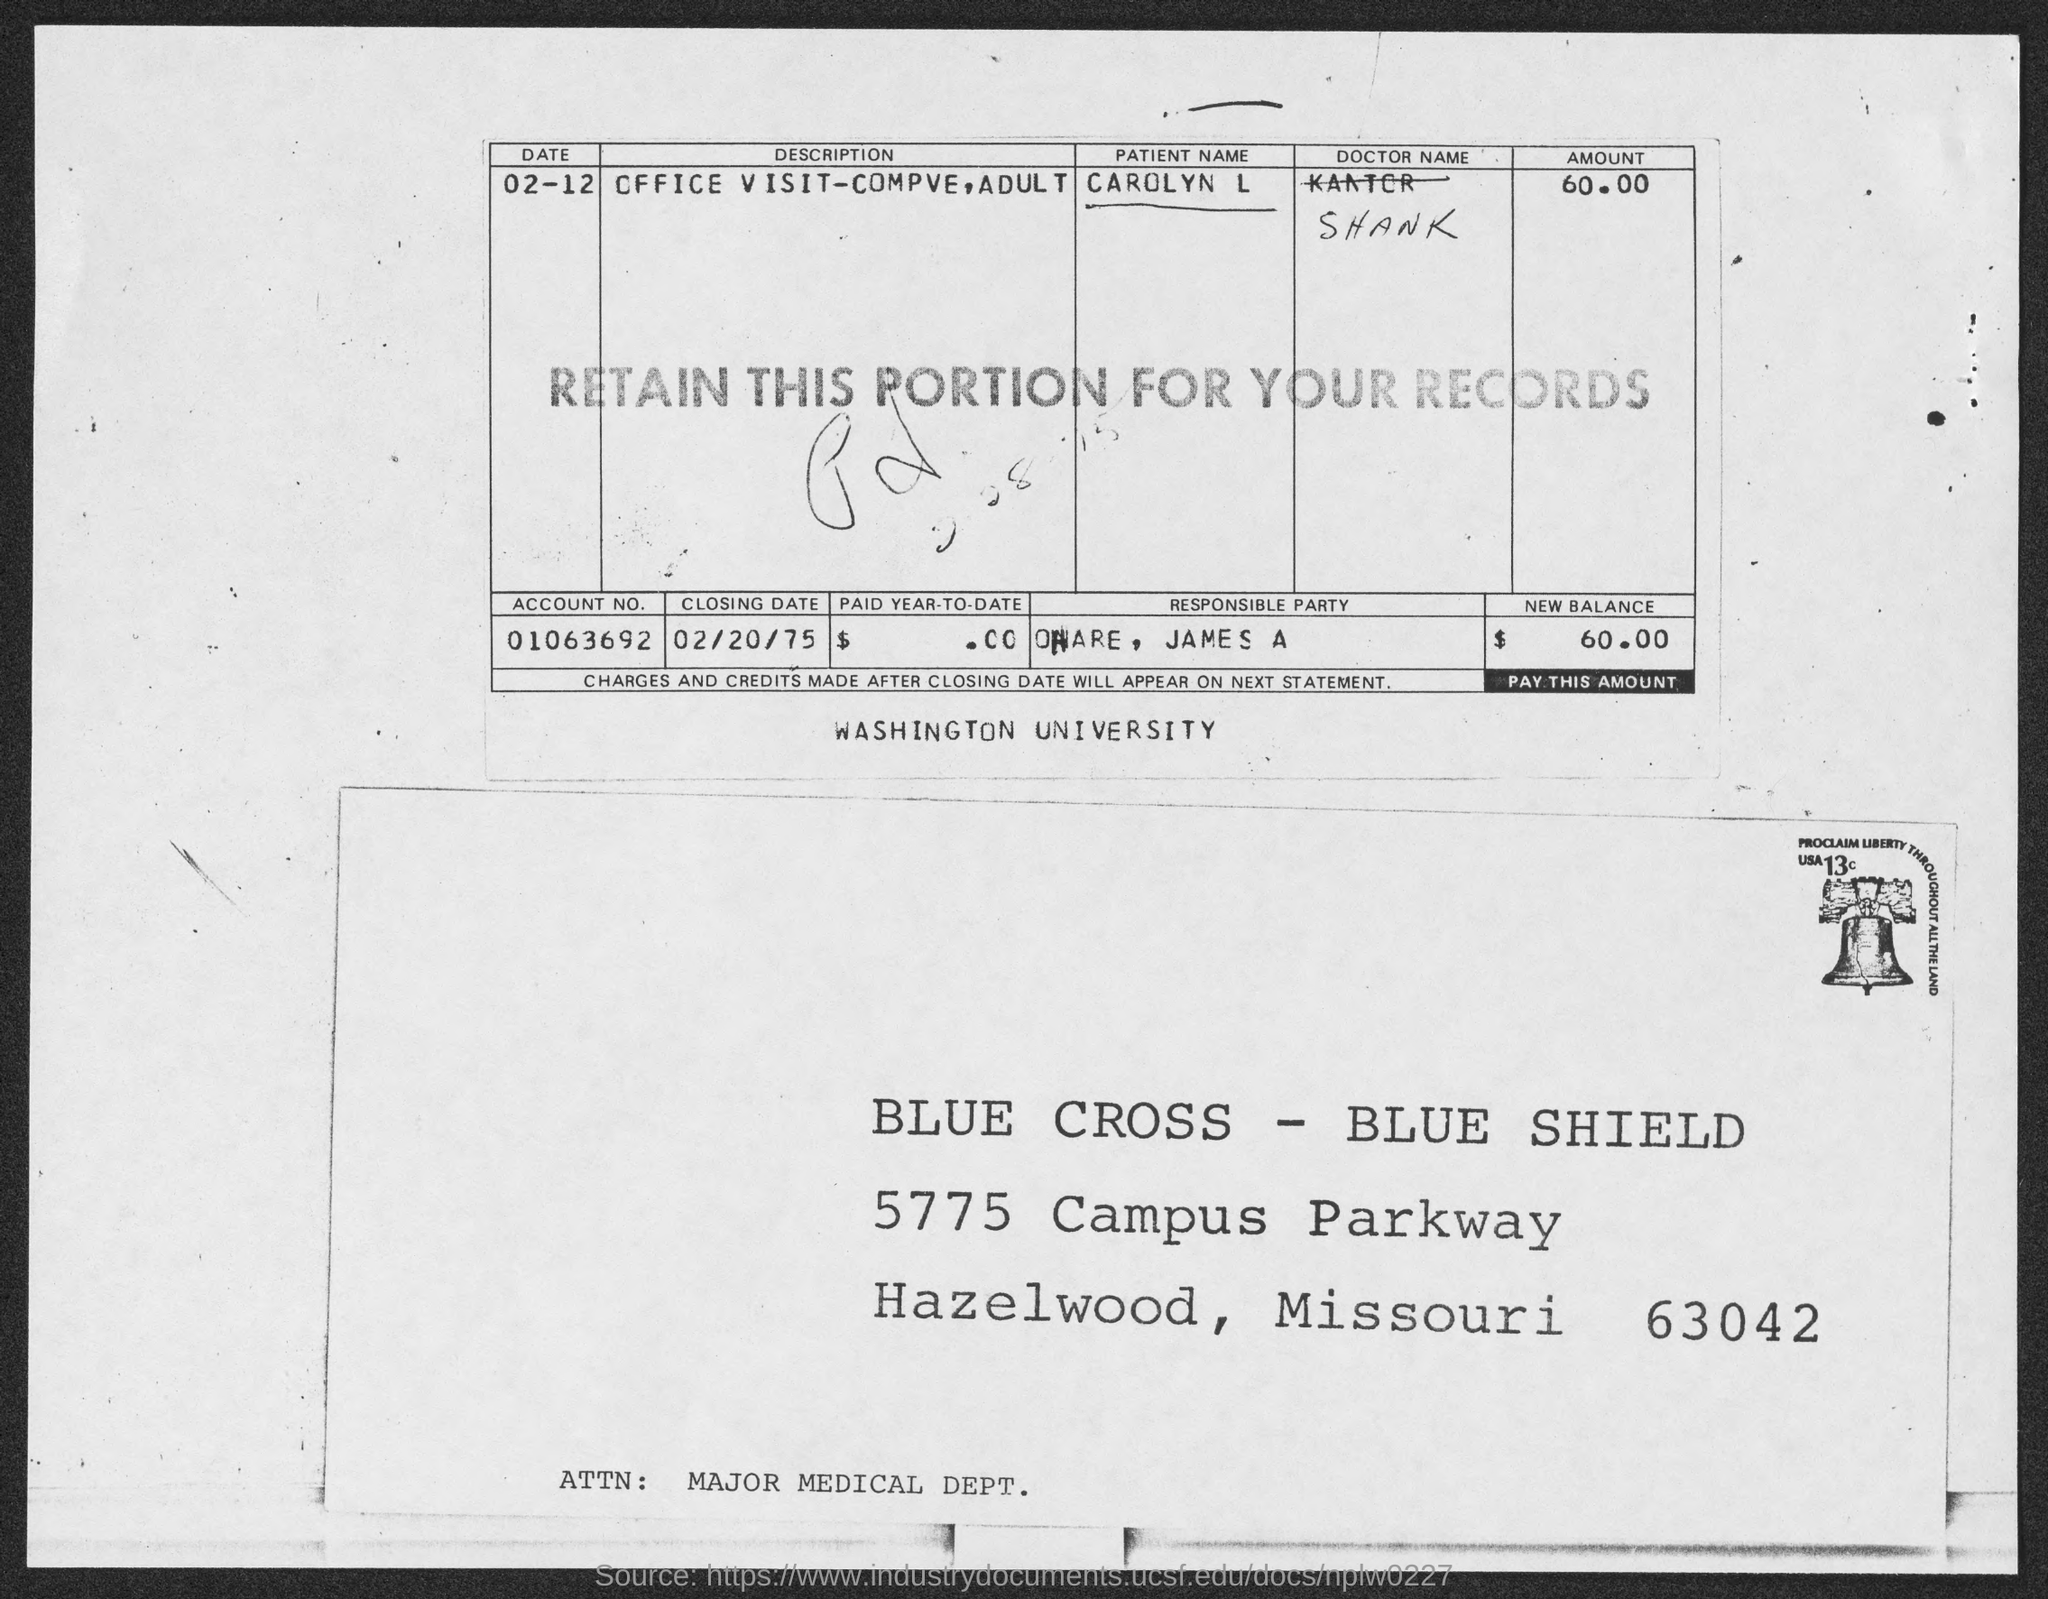Outline some significant characteristics in this image. The amount owed, or the "New balance," is $60.00. The amount mentioned in the table is 60.00. The zip code mentioned in the address is 63042. The account number mentioned in the table is 01063692... The closing date mentioned in the table is February 20, 1975. 